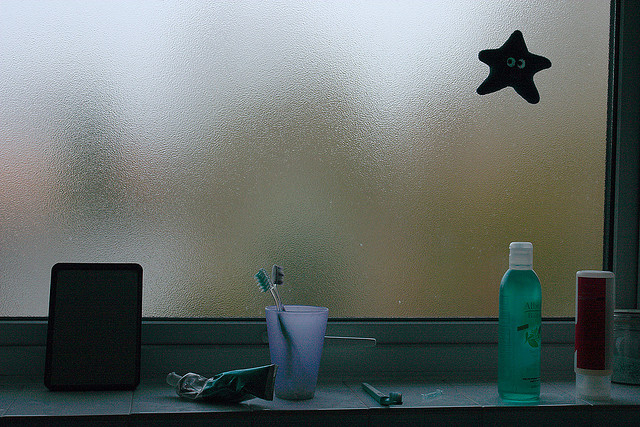Could you elaborate on the importance of the starfish decoration in this setting? The starfish decoration adds a playful and personal touch to the otherwise utilitarian space. It might reflect the owners' appreciation for oceanic or nautical themes, possibly hinting at personal memories related to the sea. This small decorative element personalizes the space, providing a cheerful contrast to the more mundane items and suggesting a love for unique, personal decor. 